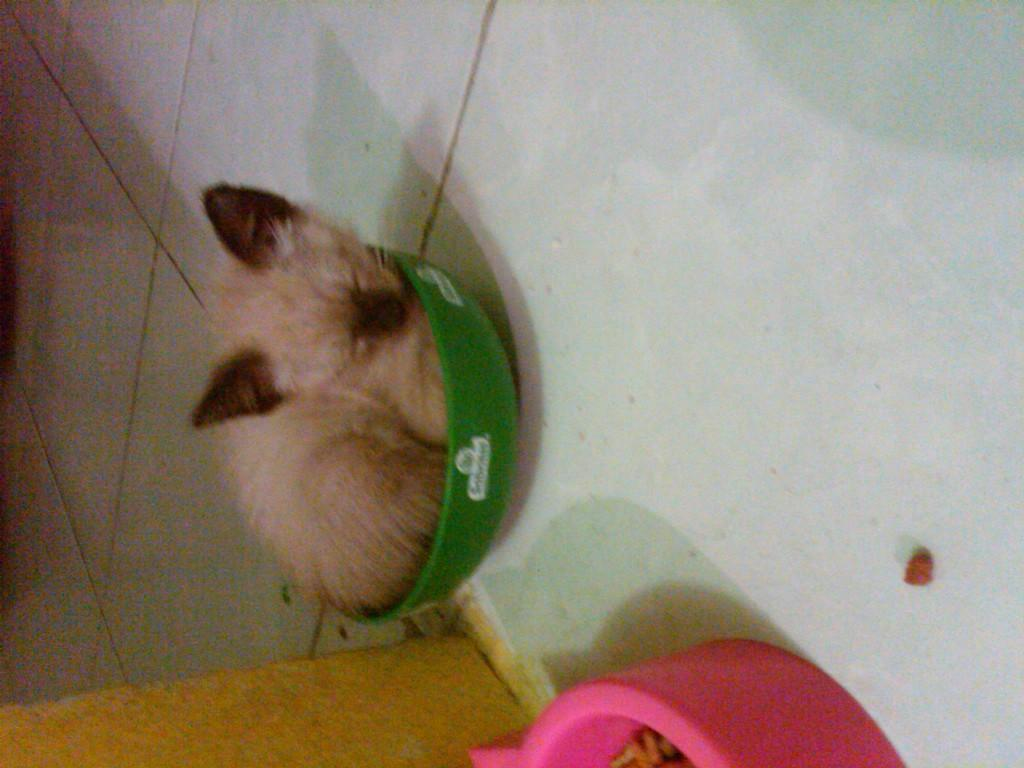What object is present in the image? There is a bowl in the image. What is the unusual aspect of the bowl in the image? A cat is sleeping in the bowl. What part of the room can be seen at the bottom of the image? The floor is visible at the bottom of the image. What theory is the cat discussing with the bowl in the image? There is no indication in the image that the cat is discussing any theory with the bowl. 